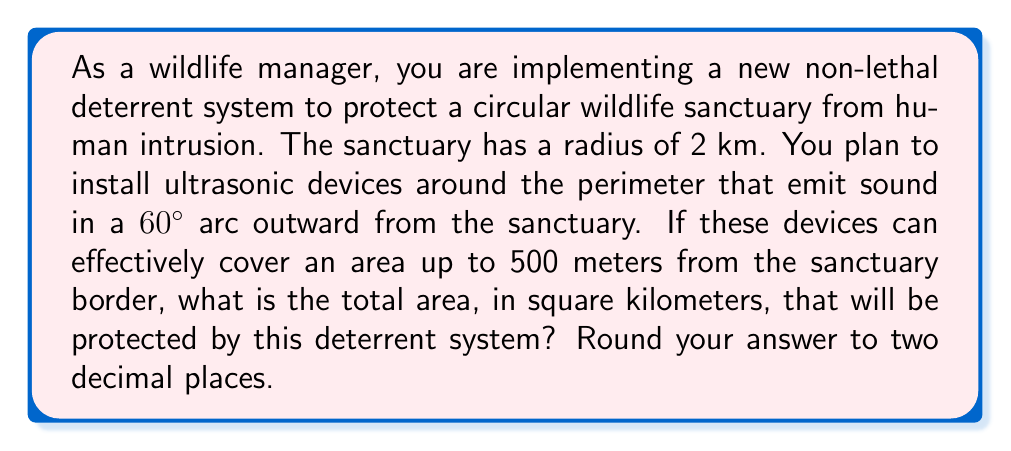Can you answer this question? To solve this problem, we need to calculate the area of the sanctuary itself plus the area of the outer ring covered by the deterrent devices. Let's break it down step by step:

1. Calculate the area of the circular sanctuary:
   $$A_{sanctuary} = \pi r^2 = \pi (2\text{ km})^2 = 4\pi \text{ km}^2$$

2. Calculate the area of the larger circle that includes the deterrent coverage:
   The radius of this circle is the sanctuary radius plus the deterrent range.
   $$r_{total} = 2\text{ km} + 0.5\text{ km} = 2.5\text{ km}$$
   $$A_{total} = \pi r_{total}^2 = \pi (2.5\text{ km})^2 = 6.25\pi \text{ km}^2$$

3. Calculate the area of the ring covered by deterrents:
   $$A_{ring} = A_{total} - A_{sanctuary} = 6.25\pi \text{ km}^2 - 4\pi \text{ km}^2 = 2.25\pi \text{ km}^2$$

4. Calculate the fraction of the ring actually covered by deterrents:
   The devices cover a 60° arc, which is $\frac{60}{360} = \frac{1}{6}$ of the full circle.
   $$A_{covered} = \frac{1}{6} \cdot A_{ring} = \frac{1}{6} \cdot 2.25\pi \text{ km}^2 = 0.375\pi \text{ km}^2$$

5. Calculate the total protected area:
   $$A_{protected} = A_{sanctuary} + A_{covered} = 4\pi \text{ km}^2 + 0.375\pi \text{ km}^2 = 4.375\pi \text{ km}^2$$

6. Convert to a numerical value and round to two decimal places:
   $$A_{protected} = 4.375\pi \text{ km}^2 \approx 13.74 \text{ km}^2$$

[asy]
unitsize(30);
fill(circle((0,0),2), rgb(0.8,0.9,1));
draw(circle((0,0),2));
draw(circle((0,0),2.5));
draw(arc((0,0),2.5,0,60));
draw(arc((0,0),2.5,120,180));
draw(arc((0,0),2.5,240,300));
label("2 km", (1,0), E);
label("0.5 km", (2.25,0), E);
label("60°", (1.5,0.5), NE);
[/asy]
Answer: 13.74 km² 